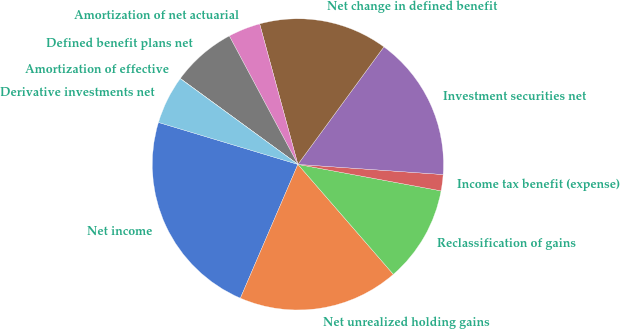Convert chart. <chart><loc_0><loc_0><loc_500><loc_500><pie_chart><fcel>Net income<fcel>Net unrealized holding gains<fcel>Reclassification of gains<fcel>Income tax benefit (expense)<fcel>Investment securities net<fcel>Net change in defined benefit<fcel>Amortization of net actuarial<fcel>Defined benefit plans net<fcel>Amortization of effective<fcel>Derivative investments net<nl><fcel>23.19%<fcel>17.84%<fcel>10.71%<fcel>1.8%<fcel>16.06%<fcel>14.28%<fcel>3.58%<fcel>7.15%<fcel>0.02%<fcel>5.37%<nl></chart> 